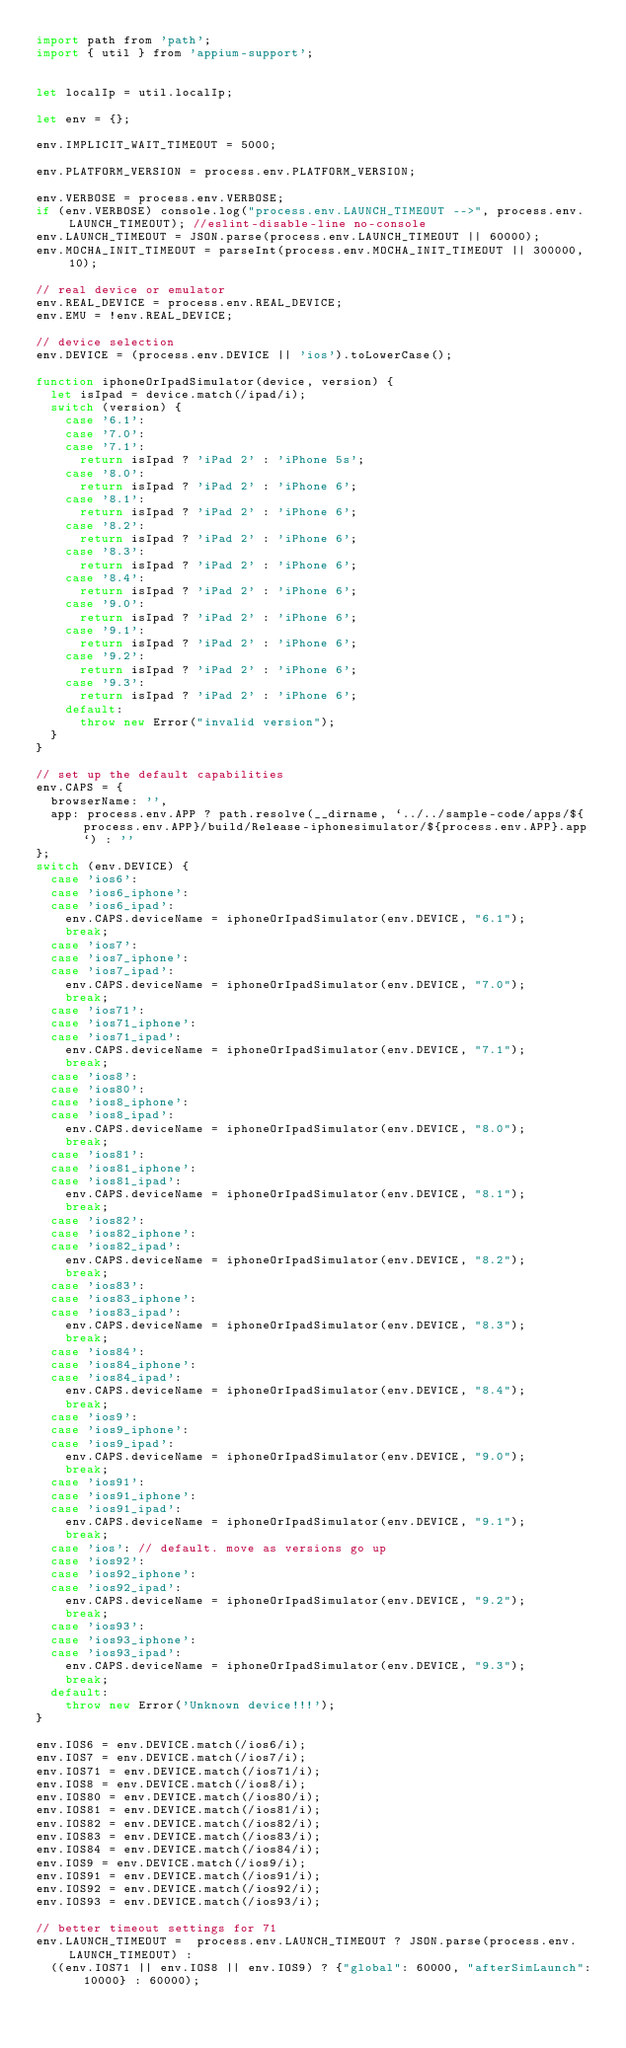<code> <loc_0><loc_0><loc_500><loc_500><_JavaScript_>import path from 'path';
import { util } from 'appium-support';


let localIp = util.localIp;

let env = {};

env.IMPLICIT_WAIT_TIMEOUT = 5000;

env.PLATFORM_VERSION = process.env.PLATFORM_VERSION;

env.VERBOSE = process.env.VERBOSE;
if (env.VERBOSE) console.log("process.env.LAUNCH_TIMEOUT -->", process.env.LAUNCH_TIMEOUT); //eslint-disable-line no-console
env.LAUNCH_TIMEOUT = JSON.parse(process.env.LAUNCH_TIMEOUT || 60000);
env.MOCHA_INIT_TIMEOUT = parseInt(process.env.MOCHA_INIT_TIMEOUT || 300000, 10);

// real device or emulator
env.REAL_DEVICE = process.env.REAL_DEVICE;
env.EMU = !env.REAL_DEVICE;

// device selection
env.DEVICE = (process.env.DEVICE || 'ios').toLowerCase();

function iphoneOrIpadSimulator(device, version) {
  let isIpad = device.match(/ipad/i);
  switch (version) {
    case '6.1':
    case '7.0':
    case '7.1':
      return isIpad ? 'iPad 2' : 'iPhone 5s';
    case '8.0':
      return isIpad ? 'iPad 2' : 'iPhone 6';
    case '8.1':
      return isIpad ? 'iPad 2' : 'iPhone 6';
    case '8.2':
      return isIpad ? 'iPad 2' : 'iPhone 6';
    case '8.3':
      return isIpad ? 'iPad 2' : 'iPhone 6';
    case '8.4':
      return isIpad ? 'iPad 2' : 'iPhone 6';
    case '9.0':
      return isIpad ? 'iPad 2' : 'iPhone 6';
    case '9.1':
      return isIpad ? 'iPad 2' : 'iPhone 6';
    case '9.2':
      return isIpad ? 'iPad 2' : 'iPhone 6';
    case '9.3':
      return isIpad ? 'iPad 2' : 'iPhone 6';
    default:
      throw new Error("invalid version");
  }
}

// set up the default capabilities
env.CAPS = {
  browserName: '',
  app: process.env.APP ? path.resolve(__dirname, `../../sample-code/apps/${process.env.APP}/build/Release-iphonesimulator/${process.env.APP}.app`) : ''
};
switch (env.DEVICE) {
  case 'ios6':
  case 'ios6_iphone':
  case 'ios6_ipad':
    env.CAPS.deviceName = iphoneOrIpadSimulator(env.DEVICE, "6.1");
    break;
  case 'ios7':
  case 'ios7_iphone':
  case 'ios7_ipad':
    env.CAPS.deviceName = iphoneOrIpadSimulator(env.DEVICE, "7.0");
    break;
  case 'ios71':
  case 'ios71_iphone':
  case 'ios71_ipad':
    env.CAPS.deviceName = iphoneOrIpadSimulator(env.DEVICE, "7.1");
    break;
  case 'ios8':
  case 'ios80':
  case 'ios8_iphone':
  case 'ios8_ipad':
    env.CAPS.deviceName = iphoneOrIpadSimulator(env.DEVICE, "8.0");
    break;
  case 'ios81':
  case 'ios81_iphone':
  case 'ios81_ipad':
    env.CAPS.deviceName = iphoneOrIpadSimulator(env.DEVICE, "8.1");
    break;
  case 'ios82':
  case 'ios82_iphone':
  case 'ios82_ipad':
    env.CAPS.deviceName = iphoneOrIpadSimulator(env.DEVICE, "8.2");
    break;
  case 'ios83':
  case 'ios83_iphone':
  case 'ios83_ipad':
    env.CAPS.deviceName = iphoneOrIpadSimulator(env.DEVICE, "8.3");
    break;
  case 'ios84':
  case 'ios84_iphone':
  case 'ios84_ipad':
    env.CAPS.deviceName = iphoneOrIpadSimulator(env.DEVICE, "8.4");
    break;
  case 'ios9':
  case 'ios9_iphone':
  case 'ios9_ipad':
    env.CAPS.deviceName = iphoneOrIpadSimulator(env.DEVICE, "9.0");
    break;
  case 'ios91':
  case 'ios91_iphone':
  case 'ios91_ipad':
    env.CAPS.deviceName = iphoneOrIpadSimulator(env.DEVICE, "9.1");
    break;
  case 'ios': // default. move as versions go up
  case 'ios92':
  case 'ios92_iphone':
  case 'ios92_ipad':
    env.CAPS.deviceName = iphoneOrIpadSimulator(env.DEVICE, "9.2");
    break;
  case 'ios93':
  case 'ios93_iphone':
  case 'ios93_ipad':
    env.CAPS.deviceName = iphoneOrIpadSimulator(env.DEVICE, "9.3");
    break;
  default:
    throw new Error('Unknown device!!!');
}

env.IOS6 = env.DEVICE.match(/ios6/i);
env.IOS7 = env.DEVICE.match(/ios7/i);
env.IOS71 = env.DEVICE.match(/ios71/i);
env.IOS8 = env.DEVICE.match(/ios8/i);
env.IOS80 = env.DEVICE.match(/ios80/i);
env.IOS81 = env.DEVICE.match(/ios81/i);
env.IOS82 = env.DEVICE.match(/ios82/i);
env.IOS83 = env.DEVICE.match(/ios83/i);
env.IOS84 = env.DEVICE.match(/ios84/i);
env.IOS9 = env.DEVICE.match(/ios9/i);
env.IOS91 = env.DEVICE.match(/ios91/i);
env.IOS92 = env.DEVICE.match(/ios92/i);
env.IOS93 = env.DEVICE.match(/ios93/i);

// better timeout settings for 71
env.LAUNCH_TIMEOUT =  process.env.LAUNCH_TIMEOUT ? JSON.parse(process.env.LAUNCH_TIMEOUT) :
  ((env.IOS71 || env.IOS8 || env.IOS9) ? {"global": 60000, "afterSimLaunch": 10000} : 60000);
</code> 